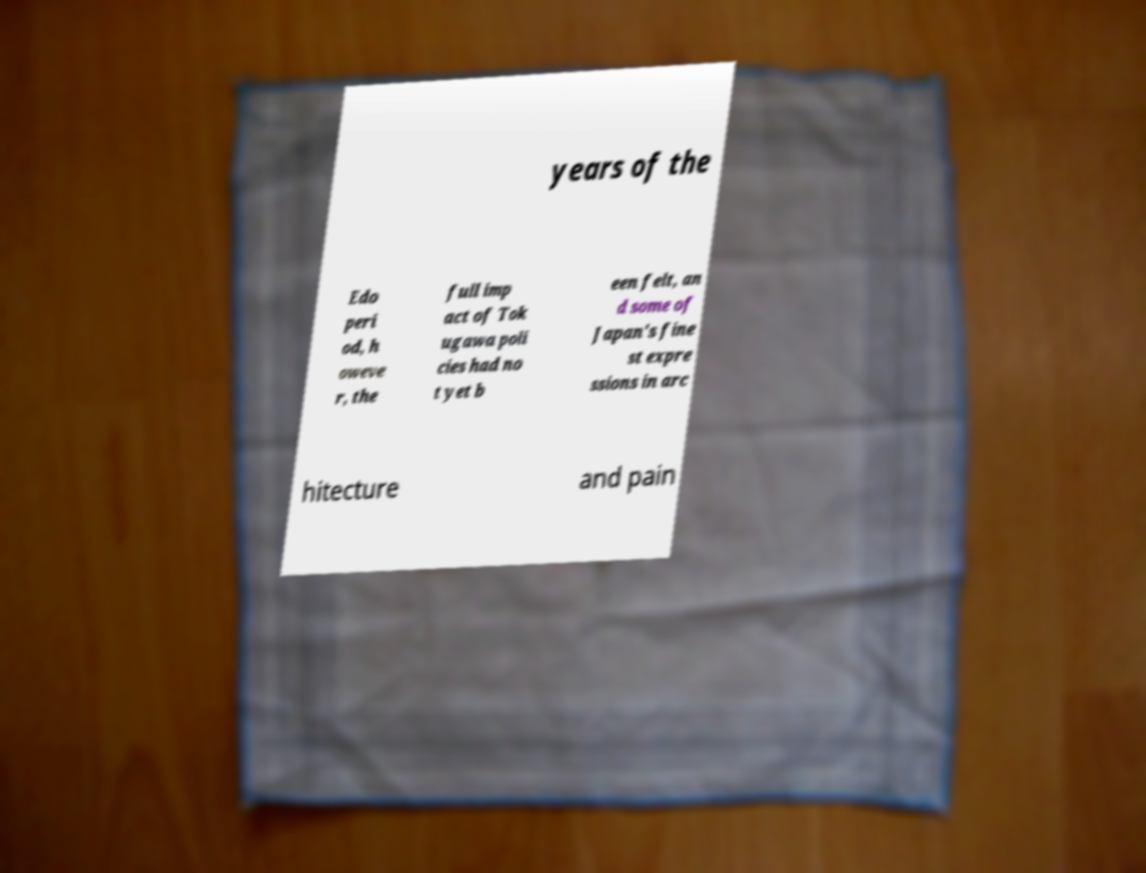Please read and relay the text visible in this image. What does it say? years of the Edo peri od, h oweve r, the full imp act of Tok ugawa poli cies had no t yet b een felt, an d some of Japan's fine st expre ssions in arc hitecture and pain 